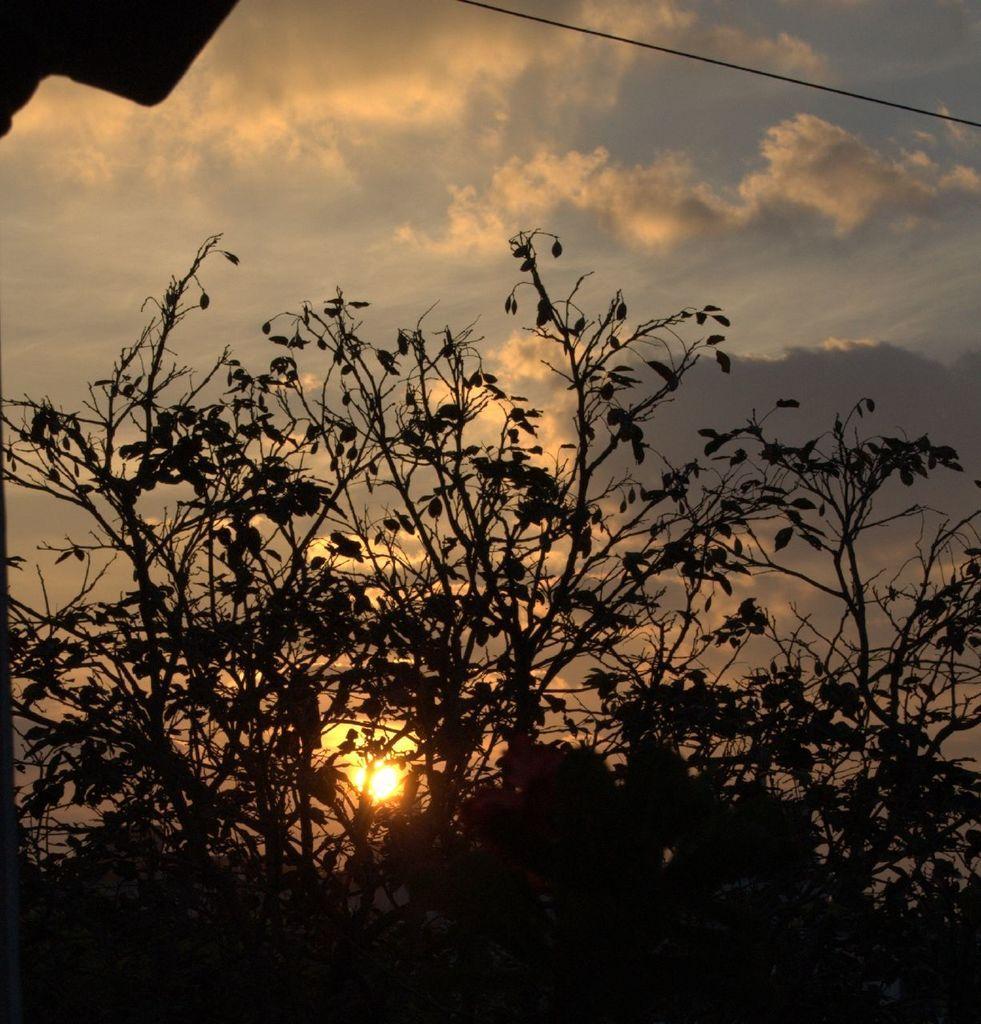Please provide a concise description of this image. Here in this picture we can see trees present over there and we can see clouds and sun in the sky over there. 